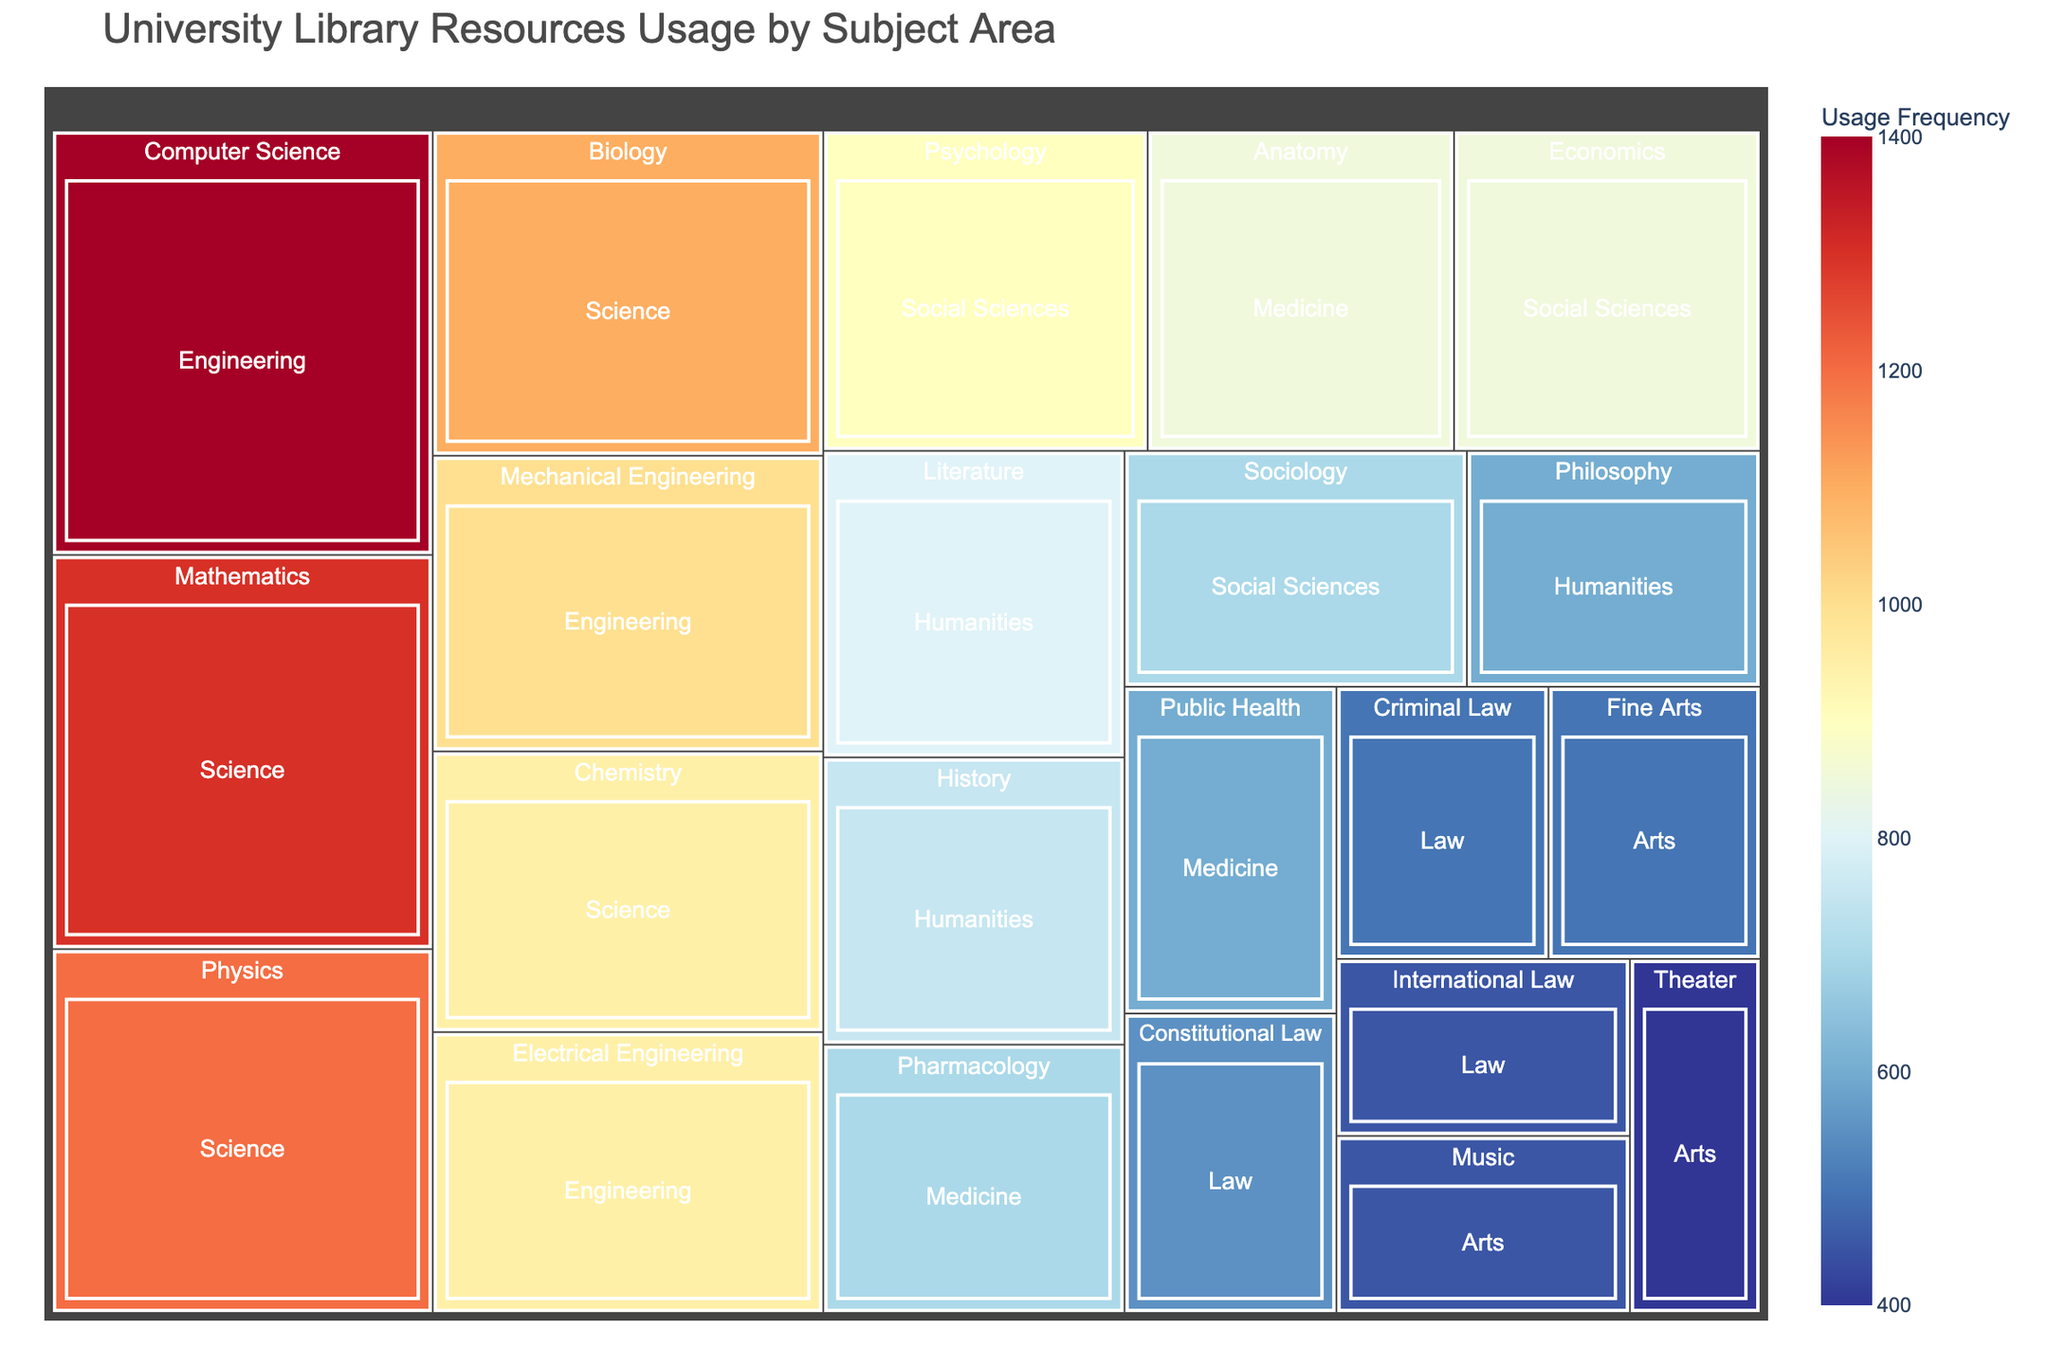How many categories are there in total? Visually, you can count the distinct categories in the Treemap. The categories are Science, Humanities, Social Sciences, Engineering, Medicine, Arts, and Law.
Answer: 7 Which subject has the highest usage frequency? In the Treemap, look for the subject with the largest area or highest color intensity. "Computer Science" under "Engineering" has the highest value of 1400.
Answer: Computer Science What's the combined usage frequency for subjects under the Arts category? Add the usage frequencies for Fine Arts (500), Music (450), and Theater (400). So, 500 + 450 + 400 = 1350.
Answer: 1350 Which category has the lowest total usage frequency? Sum the usage frequencies within each category and compare. Law has subjects with frequencies 550, 500, and 450, summing to 1500. This is lower than the sums of other categories.
Answer: Law Compare the usage frequencies of Literature and Psychology. Which one is higher? Find both subjects in the Treemap. Literature is 800, and Psychology is 900. Therefore, Psychology has a higher frequency.
Answer: Psychology What's the average usage frequency of the subjects in the Medicine category? Add the usage frequencies of Anatomy (850), Pharmacology (700), and Public Health (600), then divide by 3. So, (850 + 700 + 600) / 3 = 2150 / 3 ≈ 716.67.
Answer: 716.67 Which has a higher usage frequency: Chemistry or Mechanical Engineering? Compare the given frequencies directly. Chemistry has 950, while Mechanical Engineering has 1000. Mechanical Engineering is higher.
Answer: Mechanical Engineering What's the color scheme used in the Treemap indicative of? The Treemap uses a color scale ranging from shades of blue (lower usage) to shades of red (higher usage), which indicates the frequency of usage visually.
Answer: Usage frequency Which category has the most uniform usage frequencies among its subjects? Observe the categories and compare the level of variability. Social Sciences seems the most uniform with Psychology (900), Sociology (700), and Economics (850) being close in values.
Answer: Social Sciences 